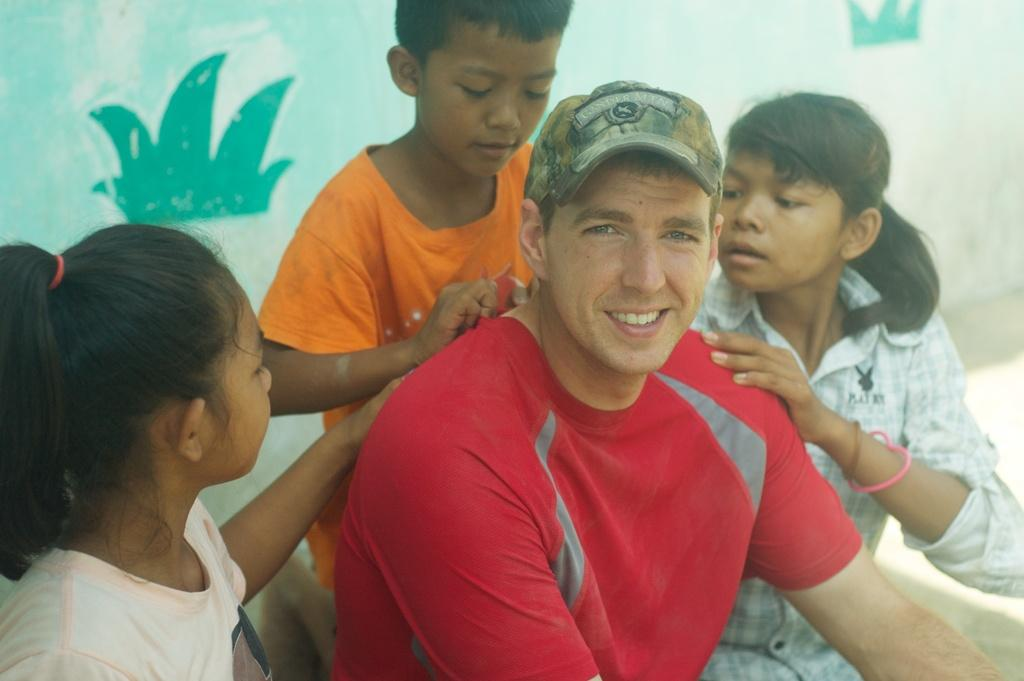Who is present in the image? There is a man in the image. What is the man doing in the image? The man is sitting alone in the image. Are there any other people in the image besides the man? Yes, there are three kids in the image. What type of card is the man holding in the image? There is no card present in the image. What effect does the glue have on the man in the image? There is no glue present in the image, so it cannot have any effect on the man. 